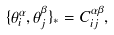<formula> <loc_0><loc_0><loc_500><loc_500>\{ \theta ^ { \alpha } _ { i } , \theta ^ { \beta } _ { j } \} _ { * } = C ^ { \alpha \beta } _ { i j } ,</formula> 